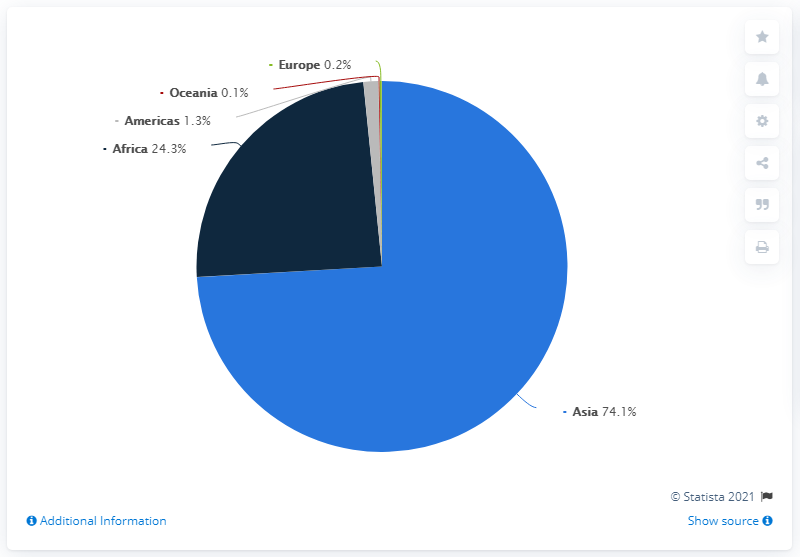Draw attention to some important aspects in this diagram. In Africa and Asia, the share of people affected by natural disasters varies, with a higher proportion of affected individuals in Africa at 49.8%. The region with the highest proportion of individuals affected by natural disasters is Asia. In 2019, 74.1 percent of people affected by natural disasters lived in Asia. 